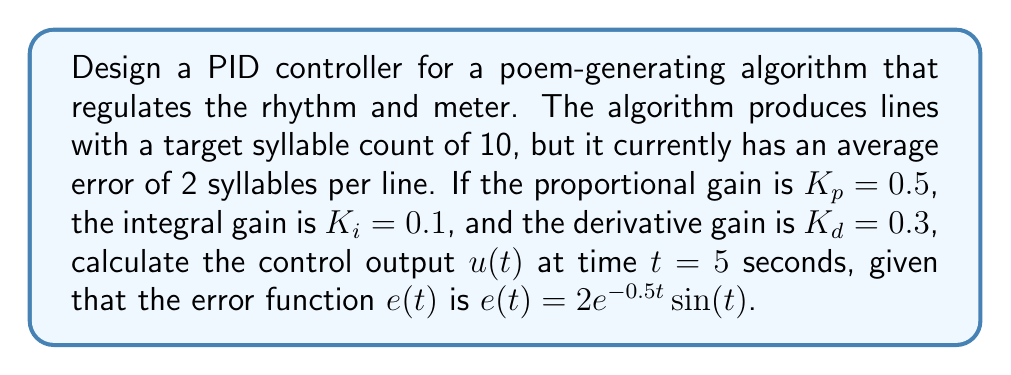Help me with this question. To solve this problem, we need to use the PID controller equation and calculate each component:

1. The PID controller equation is:
   $$u(t) = K_p e(t) + K_i \int_0^t e(\tau) d\tau + K_d \frac{de(t)}{dt}$$

2. Given error function: $e(t) = 2e^{-0.5t}\sin(t)$

3. Calculate the integral of the error function:
   $$\int_0^t e(\tau) d\tau = \int_0^t 2e^{-0.5\tau}\sin(\tau) d\tau$$
   $$= -4e^{-0.5t}(\sin(t) + 0.5\cos(t)) + 2$$

4. Calculate the derivative of the error function:
   $$\frac{de(t)}{dt} = 2e^{-0.5t}(\cos(t) - 0.5\sin(t))$$

5. Now, substitute $t = 5$ into these expressions:
   $$e(5) = 2e^{-0.5(5)}\sin(5) \approx 0.2725$$
   $$\int_0^5 e(\tau) d\tau \approx 0.7935$$
   $$\frac{de(5)}{dt} \approx -0.3678$$

6. Finally, calculate the control output $u(5)$:
   $$u(5) = K_p e(5) + K_i \int_0^5 e(\tau) d\tau + K_d \frac{de(5)}{dt}$$
   $$u(5) = 0.5(0.2725) + 0.1(0.7935) + 0.3(-0.3678)$$
   $$u(5) = 0.13625 + 0.07935 - 0.11034$$
Answer: $u(5) \approx 0.10526$ 